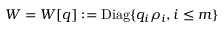<formula> <loc_0><loc_0><loc_500><loc_500>W = W [ q ] \colon = { D i a g } \{ q _ { i } \rho _ { i } , i \leq m \}</formula> 